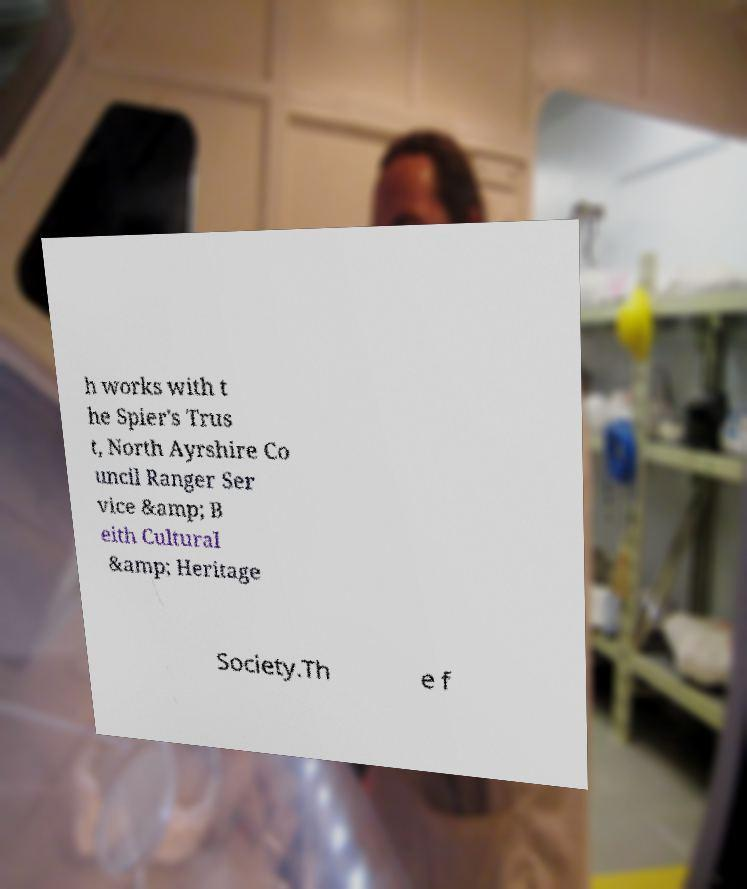There's text embedded in this image that I need extracted. Can you transcribe it verbatim? h works with t he Spier's Trus t, North Ayrshire Co uncil Ranger Ser vice &amp; B eith Cultural &amp; Heritage Society.Th e f 